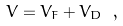<formula> <loc_0><loc_0><loc_500><loc_500>V = V _ { F } + V _ { D } \ ,</formula> 